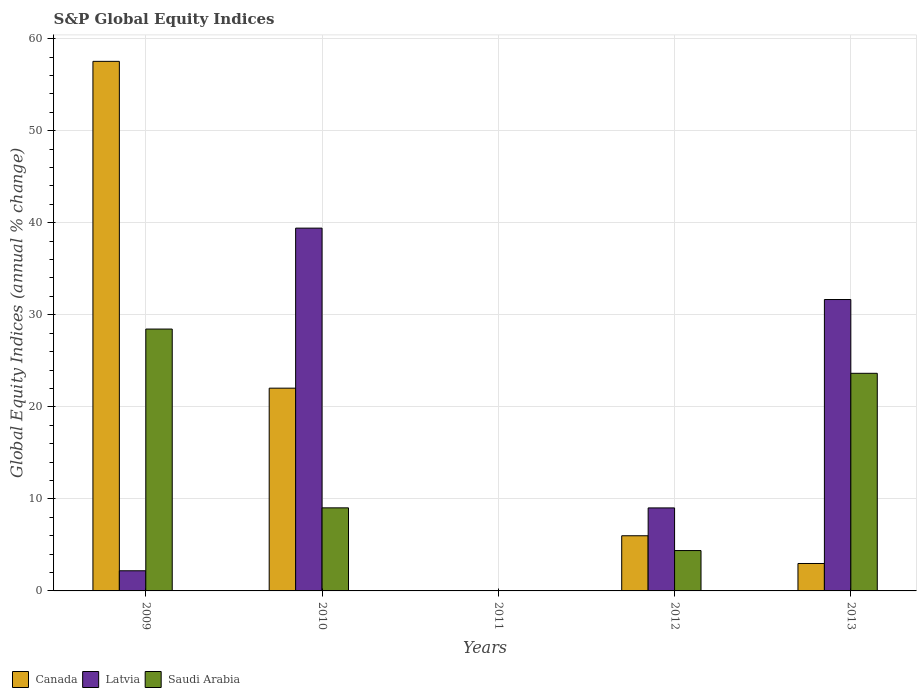How many bars are there on the 5th tick from the left?
Your response must be concise. 3. What is the label of the 3rd group of bars from the left?
Keep it short and to the point. 2011. In how many cases, is the number of bars for a given year not equal to the number of legend labels?
Ensure brevity in your answer.  1. What is the global equity indices in Canada in 2013?
Your response must be concise. 2.98. Across all years, what is the maximum global equity indices in Latvia?
Make the answer very short. 39.41. Across all years, what is the minimum global equity indices in Canada?
Keep it short and to the point. 0. What is the total global equity indices in Canada in the graph?
Give a very brief answer. 88.53. What is the difference between the global equity indices in Latvia in 2009 and that in 2013?
Provide a succinct answer. -29.47. What is the difference between the global equity indices in Saudi Arabia in 2009 and the global equity indices in Latvia in 2013?
Give a very brief answer. -3.21. What is the average global equity indices in Latvia per year?
Make the answer very short. 16.46. In the year 2009, what is the difference between the global equity indices in Latvia and global equity indices in Saudi Arabia?
Provide a succinct answer. -26.26. What is the ratio of the global equity indices in Latvia in 2009 to that in 2013?
Offer a terse response. 0.07. What is the difference between the highest and the second highest global equity indices in Latvia?
Offer a terse response. 7.76. What is the difference between the highest and the lowest global equity indices in Canada?
Your response must be concise. 57.53. In how many years, is the global equity indices in Canada greater than the average global equity indices in Canada taken over all years?
Offer a very short reply. 2. Are all the bars in the graph horizontal?
Your response must be concise. No. What is the difference between two consecutive major ticks on the Y-axis?
Offer a terse response. 10. Does the graph contain any zero values?
Ensure brevity in your answer.  Yes. What is the title of the graph?
Your response must be concise. S&P Global Equity Indices. Does "Oman" appear as one of the legend labels in the graph?
Give a very brief answer. No. What is the label or title of the Y-axis?
Ensure brevity in your answer.  Global Equity Indices (annual % change). What is the Global Equity Indices (annual % change) of Canada in 2009?
Offer a terse response. 57.53. What is the Global Equity Indices (annual % change) in Latvia in 2009?
Make the answer very short. 2.19. What is the Global Equity Indices (annual % change) of Saudi Arabia in 2009?
Keep it short and to the point. 28.45. What is the Global Equity Indices (annual % change) in Canada in 2010?
Your answer should be compact. 22.03. What is the Global Equity Indices (annual % change) of Latvia in 2010?
Your answer should be very brief. 39.41. What is the Global Equity Indices (annual % change) in Saudi Arabia in 2010?
Your answer should be compact. 9.02. What is the Global Equity Indices (annual % change) of Canada in 2012?
Your answer should be compact. 5.99. What is the Global Equity Indices (annual % change) of Latvia in 2012?
Your answer should be compact. 9.02. What is the Global Equity Indices (annual % change) of Saudi Arabia in 2012?
Give a very brief answer. 4.39. What is the Global Equity Indices (annual % change) in Canada in 2013?
Your answer should be very brief. 2.98. What is the Global Equity Indices (annual % change) in Latvia in 2013?
Make the answer very short. 31.66. What is the Global Equity Indices (annual % change) in Saudi Arabia in 2013?
Ensure brevity in your answer.  23.64. Across all years, what is the maximum Global Equity Indices (annual % change) in Canada?
Ensure brevity in your answer.  57.53. Across all years, what is the maximum Global Equity Indices (annual % change) in Latvia?
Give a very brief answer. 39.41. Across all years, what is the maximum Global Equity Indices (annual % change) in Saudi Arabia?
Provide a short and direct response. 28.45. Across all years, what is the minimum Global Equity Indices (annual % change) in Saudi Arabia?
Provide a short and direct response. 0. What is the total Global Equity Indices (annual % change) in Canada in the graph?
Make the answer very short. 88.53. What is the total Global Equity Indices (annual % change) in Latvia in the graph?
Offer a terse response. 82.28. What is the total Global Equity Indices (annual % change) of Saudi Arabia in the graph?
Ensure brevity in your answer.  65.5. What is the difference between the Global Equity Indices (annual % change) in Canada in 2009 and that in 2010?
Give a very brief answer. 35.51. What is the difference between the Global Equity Indices (annual % change) of Latvia in 2009 and that in 2010?
Make the answer very short. -37.22. What is the difference between the Global Equity Indices (annual % change) in Saudi Arabia in 2009 and that in 2010?
Offer a very short reply. 19.43. What is the difference between the Global Equity Indices (annual % change) in Canada in 2009 and that in 2012?
Provide a succinct answer. 51.54. What is the difference between the Global Equity Indices (annual % change) of Latvia in 2009 and that in 2012?
Give a very brief answer. -6.83. What is the difference between the Global Equity Indices (annual % change) in Saudi Arabia in 2009 and that in 2012?
Ensure brevity in your answer.  24.06. What is the difference between the Global Equity Indices (annual % change) in Canada in 2009 and that in 2013?
Provide a succinct answer. 54.55. What is the difference between the Global Equity Indices (annual % change) of Latvia in 2009 and that in 2013?
Your response must be concise. -29.47. What is the difference between the Global Equity Indices (annual % change) in Saudi Arabia in 2009 and that in 2013?
Keep it short and to the point. 4.81. What is the difference between the Global Equity Indices (annual % change) of Canada in 2010 and that in 2012?
Offer a very short reply. 16.03. What is the difference between the Global Equity Indices (annual % change) of Latvia in 2010 and that in 2012?
Your answer should be compact. 30.4. What is the difference between the Global Equity Indices (annual % change) in Saudi Arabia in 2010 and that in 2012?
Your answer should be compact. 4.64. What is the difference between the Global Equity Indices (annual % change) of Canada in 2010 and that in 2013?
Provide a short and direct response. 19.05. What is the difference between the Global Equity Indices (annual % change) in Latvia in 2010 and that in 2013?
Your response must be concise. 7.76. What is the difference between the Global Equity Indices (annual % change) in Saudi Arabia in 2010 and that in 2013?
Provide a short and direct response. -14.62. What is the difference between the Global Equity Indices (annual % change) of Canada in 2012 and that in 2013?
Provide a succinct answer. 3.01. What is the difference between the Global Equity Indices (annual % change) in Latvia in 2012 and that in 2013?
Offer a terse response. -22.64. What is the difference between the Global Equity Indices (annual % change) of Saudi Arabia in 2012 and that in 2013?
Make the answer very short. -19.26. What is the difference between the Global Equity Indices (annual % change) of Canada in 2009 and the Global Equity Indices (annual % change) of Latvia in 2010?
Your answer should be compact. 18.12. What is the difference between the Global Equity Indices (annual % change) of Canada in 2009 and the Global Equity Indices (annual % change) of Saudi Arabia in 2010?
Keep it short and to the point. 48.51. What is the difference between the Global Equity Indices (annual % change) of Latvia in 2009 and the Global Equity Indices (annual % change) of Saudi Arabia in 2010?
Keep it short and to the point. -6.84. What is the difference between the Global Equity Indices (annual % change) in Canada in 2009 and the Global Equity Indices (annual % change) in Latvia in 2012?
Your answer should be compact. 48.52. What is the difference between the Global Equity Indices (annual % change) in Canada in 2009 and the Global Equity Indices (annual % change) in Saudi Arabia in 2012?
Provide a short and direct response. 53.15. What is the difference between the Global Equity Indices (annual % change) in Latvia in 2009 and the Global Equity Indices (annual % change) in Saudi Arabia in 2012?
Offer a very short reply. -2.2. What is the difference between the Global Equity Indices (annual % change) of Canada in 2009 and the Global Equity Indices (annual % change) of Latvia in 2013?
Your answer should be compact. 25.88. What is the difference between the Global Equity Indices (annual % change) in Canada in 2009 and the Global Equity Indices (annual % change) in Saudi Arabia in 2013?
Offer a terse response. 33.89. What is the difference between the Global Equity Indices (annual % change) in Latvia in 2009 and the Global Equity Indices (annual % change) in Saudi Arabia in 2013?
Make the answer very short. -21.45. What is the difference between the Global Equity Indices (annual % change) of Canada in 2010 and the Global Equity Indices (annual % change) of Latvia in 2012?
Make the answer very short. 13.01. What is the difference between the Global Equity Indices (annual % change) in Canada in 2010 and the Global Equity Indices (annual % change) in Saudi Arabia in 2012?
Make the answer very short. 17.64. What is the difference between the Global Equity Indices (annual % change) of Latvia in 2010 and the Global Equity Indices (annual % change) of Saudi Arabia in 2012?
Offer a very short reply. 35.03. What is the difference between the Global Equity Indices (annual % change) of Canada in 2010 and the Global Equity Indices (annual % change) of Latvia in 2013?
Your response must be concise. -9.63. What is the difference between the Global Equity Indices (annual % change) of Canada in 2010 and the Global Equity Indices (annual % change) of Saudi Arabia in 2013?
Provide a short and direct response. -1.61. What is the difference between the Global Equity Indices (annual % change) in Latvia in 2010 and the Global Equity Indices (annual % change) in Saudi Arabia in 2013?
Your answer should be compact. 15.77. What is the difference between the Global Equity Indices (annual % change) in Canada in 2012 and the Global Equity Indices (annual % change) in Latvia in 2013?
Offer a very short reply. -25.66. What is the difference between the Global Equity Indices (annual % change) in Canada in 2012 and the Global Equity Indices (annual % change) in Saudi Arabia in 2013?
Offer a terse response. -17.65. What is the difference between the Global Equity Indices (annual % change) in Latvia in 2012 and the Global Equity Indices (annual % change) in Saudi Arabia in 2013?
Offer a terse response. -14.62. What is the average Global Equity Indices (annual % change) of Canada per year?
Offer a terse response. 17.71. What is the average Global Equity Indices (annual % change) of Latvia per year?
Your response must be concise. 16.46. What is the average Global Equity Indices (annual % change) in Saudi Arabia per year?
Your answer should be very brief. 13.1. In the year 2009, what is the difference between the Global Equity Indices (annual % change) in Canada and Global Equity Indices (annual % change) in Latvia?
Offer a terse response. 55.34. In the year 2009, what is the difference between the Global Equity Indices (annual % change) in Canada and Global Equity Indices (annual % change) in Saudi Arabia?
Give a very brief answer. 29.08. In the year 2009, what is the difference between the Global Equity Indices (annual % change) in Latvia and Global Equity Indices (annual % change) in Saudi Arabia?
Offer a terse response. -26.26. In the year 2010, what is the difference between the Global Equity Indices (annual % change) of Canada and Global Equity Indices (annual % change) of Latvia?
Your response must be concise. -17.39. In the year 2010, what is the difference between the Global Equity Indices (annual % change) of Canada and Global Equity Indices (annual % change) of Saudi Arabia?
Provide a short and direct response. 13. In the year 2010, what is the difference between the Global Equity Indices (annual % change) in Latvia and Global Equity Indices (annual % change) in Saudi Arabia?
Provide a succinct answer. 30.39. In the year 2012, what is the difference between the Global Equity Indices (annual % change) in Canada and Global Equity Indices (annual % change) in Latvia?
Ensure brevity in your answer.  -3.02. In the year 2012, what is the difference between the Global Equity Indices (annual % change) in Canada and Global Equity Indices (annual % change) in Saudi Arabia?
Ensure brevity in your answer.  1.61. In the year 2012, what is the difference between the Global Equity Indices (annual % change) of Latvia and Global Equity Indices (annual % change) of Saudi Arabia?
Offer a very short reply. 4.63. In the year 2013, what is the difference between the Global Equity Indices (annual % change) in Canada and Global Equity Indices (annual % change) in Latvia?
Ensure brevity in your answer.  -28.68. In the year 2013, what is the difference between the Global Equity Indices (annual % change) of Canada and Global Equity Indices (annual % change) of Saudi Arabia?
Your answer should be very brief. -20.66. In the year 2013, what is the difference between the Global Equity Indices (annual % change) of Latvia and Global Equity Indices (annual % change) of Saudi Arabia?
Ensure brevity in your answer.  8.02. What is the ratio of the Global Equity Indices (annual % change) of Canada in 2009 to that in 2010?
Keep it short and to the point. 2.61. What is the ratio of the Global Equity Indices (annual % change) of Latvia in 2009 to that in 2010?
Ensure brevity in your answer.  0.06. What is the ratio of the Global Equity Indices (annual % change) of Saudi Arabia in 2009 to that in 2010?
Keep it short and to the point. 3.15. What is the ratio of the Global Equity Indices (annual % change) of Canada in 2009 to that in 2012?
Keep it short and to the point. 9.6. What is the ratio of the Global Equity Indices (annual % change) in Latvia in 2009 to that in 2012?
Provide a short and direct response. 0.24. What is the ratio of the Global Equity Indices (annual % change) in Saudi Arabia in 2009 to that in 2012?
Offer a terse response. 6.49. What is the ratio of the Global Equity Indices (annual % change) in Canada in 2009 to that in 2013?
Your response must be concise. 19.31. What is the ratio of the Global Equity Indices (annual % change) of Latvia in 2009 to that in 2013?
Make the answer very short. 0.07. What is the ratio of the Global Equity Indices (annual % change) in Saudi Arabia in 2009 to that in 2013?
Keep it short and to the point. 1.2. What is the ratio of the Global Equity Indices (annual % change) in Canada in 2010 to that in 2012?
Your answer should be very brief. 3.68. What is the ratio of the Global Equity Indices (annual % change) in Latvia in 2010 to that in 2012?
Your answer should be compact. 4.37. What is the ratio of the Global Equity Indices (annual % change) in Saudi Arabia in 2010 to that in 2012?
Your answer should be compact. 2.06. What is the ratio of the Global Equity Indices (annual % change) of Canada in 2010 to that in 2013?
Your answer should be compact. 7.39. What is the ratio of the Global Equity Indices (annual % change) in Latvia in 2010 to that in 2013?
Offer a very short reply. 1.25. What is the ratio of the Global Equity Indices (annual % change) of Saudi Arabia in 2010 to that in 2013?
Make the answer very short. 0.38. What is the ratio of the Global Equity Indices (annual % change) of Canada in 2012 to that in 2013?
Your response must be concise. 2.01. What is the ratio of the Global Equity Indices (annual % change) in Latvia in 2012 to that in 2013?
Your answer should be very brief. 0.28. What is the ratio of the Global Equity Indices (annual % change) in Saudi Arabia in 2012 to that in 2013?
Your response must be concise. 0.19. What is the difference between the highest and the second highest Global Equity Indices (annual % change) in Canada?
Your response must be concise. 35.51. What is the difference between the highest and the second highest Global Equity Indices (annual % change) in Latvia?
Give a very brief answer. 7.76. What is the difference between the highest and the second highest Global Equity Indices (annual % change) in Saudi Arabia?
Keep it short and to the point. 4.81. What is the difference between the highest and the lowest Global Equity Indices (annual % change) in Canada?
Give a very brief answer. 57.53. What is the difference between the highest and the lowest Global Equity Indices (annual % change) in Latvia?
Your response must be concise. 39.41. What is the difference between the highest and the lowest Global Equity Indices (annual % change) of Saudi Arabia?
Provide a short and direct response. 28.45. 